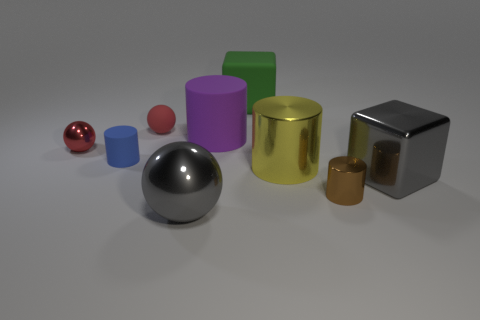There is a block that is to the left of the tiny cylinder in front of the big yellow metallic cylinder; what is its material?
Your answer should be very brief. Rubber. There is a sphere that is the same color as the metallic block; what is its material?
Offer a terse response. Metal. What color is the large metal block?
Your answer should be very brief. Gray. Are there any blue cylinders that are in front of the big gray sphere that is on the right side of the red rubber object?
Provide a succinct answer. No. What is the material of the gray ball?
Your response must be concise. Metal. Is the cube that is behind the tiny blue rubber cylinder made of the same material as the tiny cylinder that is on the left side of the gray shiny ball?
Provide a succinct answer. Yes. Are there any other things that are the same color as the big metal ball?
Your response must be concise. Yes. There is another matte thing that is the same shape as the purple rubber object; what color is it?
Offer a very short reply. Blue. What is the size of the cylinder that is to the left of the tiny brown shiny cylinder and on the right side of the purple object?
Offer a terse response. Large. Do the gray object that is behind the gray sphere and the tiny shiny thing that is in front of the red metal object have the same shape?
Your answer should be very brief. No. 